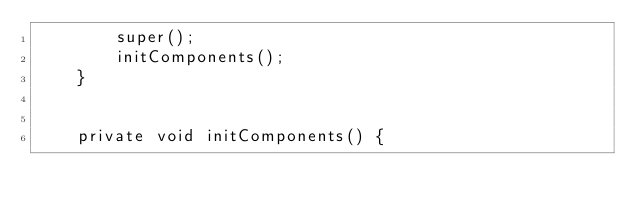Convert code to text. <code><loc_0><loc_0><loc_500><loc_500><_Java_>        super();
        initComponents();
    }

    
    private void initComponents() {
        </code> 